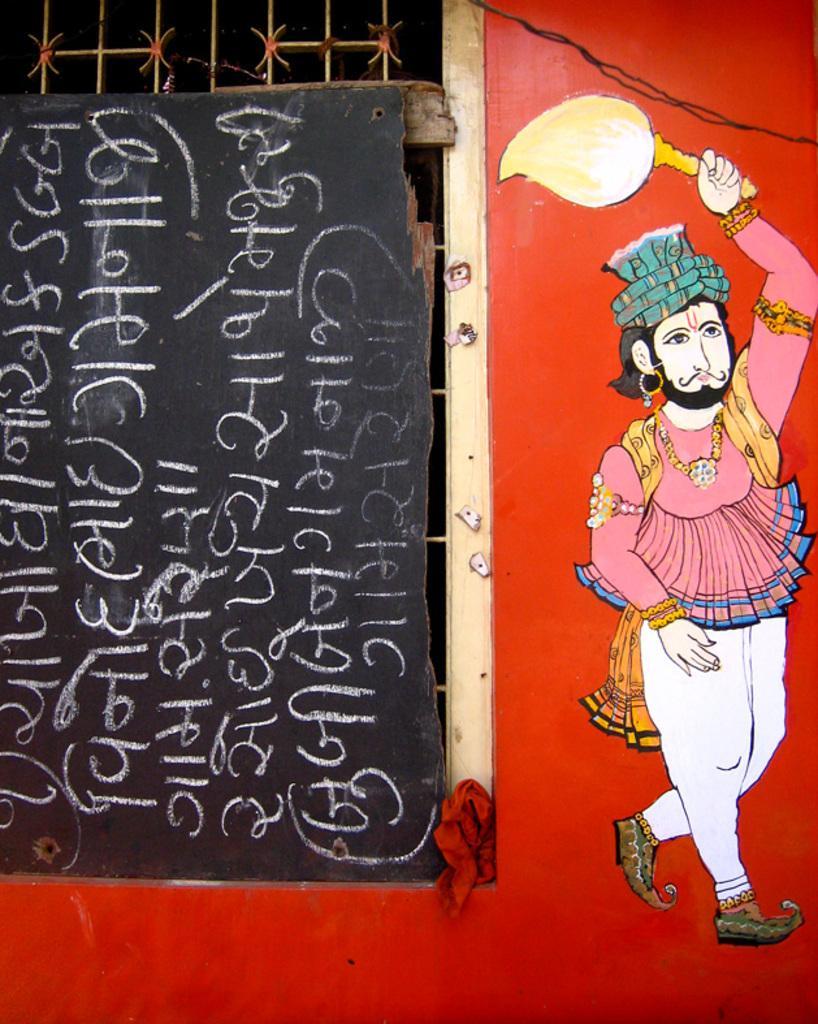How would you summarize this image in a sentence or two? In this image there is a wall having a window covered with a board having some text on it. Wall is painted with a picture of a person holding an object in his hand. 